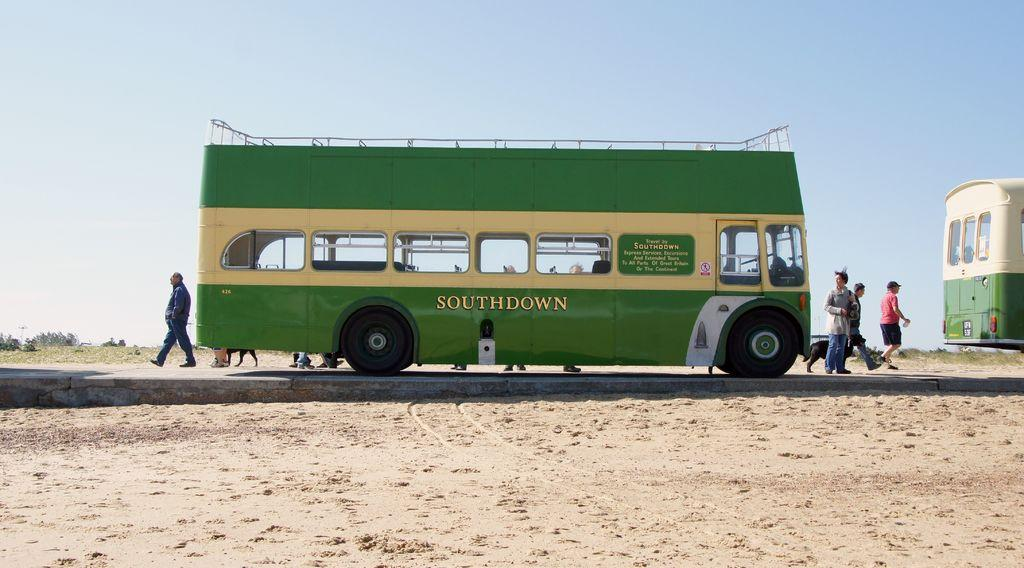Provide a one-sentence caption for the provided image. A green Southdown bus is on a road surrounded by sand. 